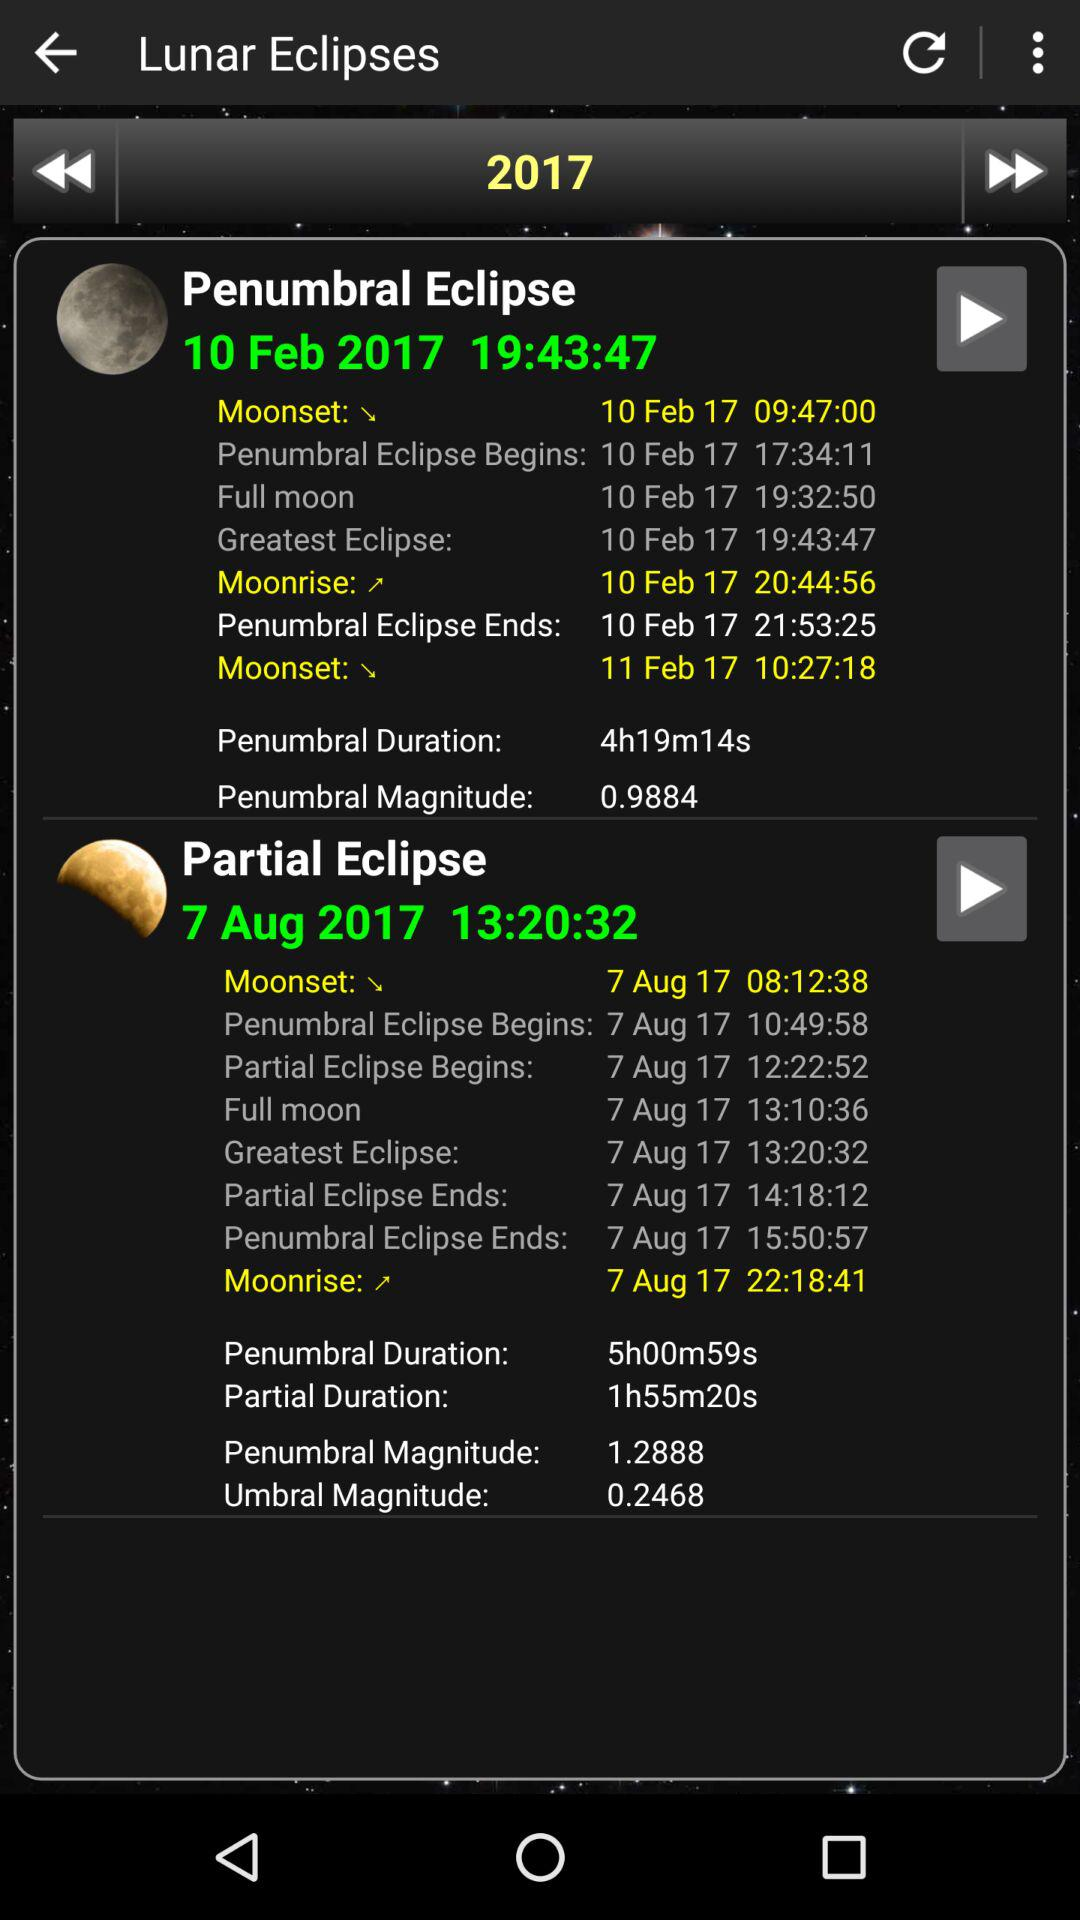What time does the penumbral eclipse begin? The penumbral eclipse begins at 17:34:11 and 10:49:58. 